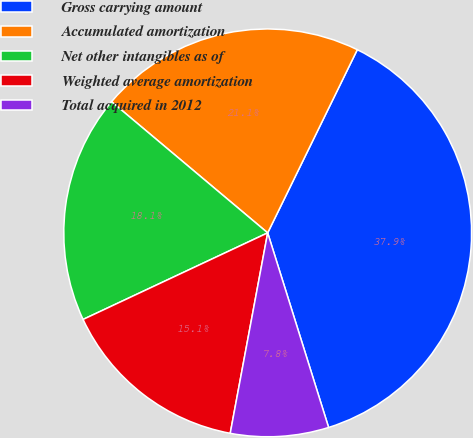<chart> <loc_0><loc_0><loc_500><loc_500><pie_chart><fcel>Gross carrying amount<fcel>Accumulated amortization<fcel>Net other intangibles as of<fcel>Weighted average amortization<fcel>Total acquired in 2012<nl><fcel>37.93%<fcel>21.12%<fcel>18.1%<fcel>15.08%<fcel>7.77%<nl></chart> 